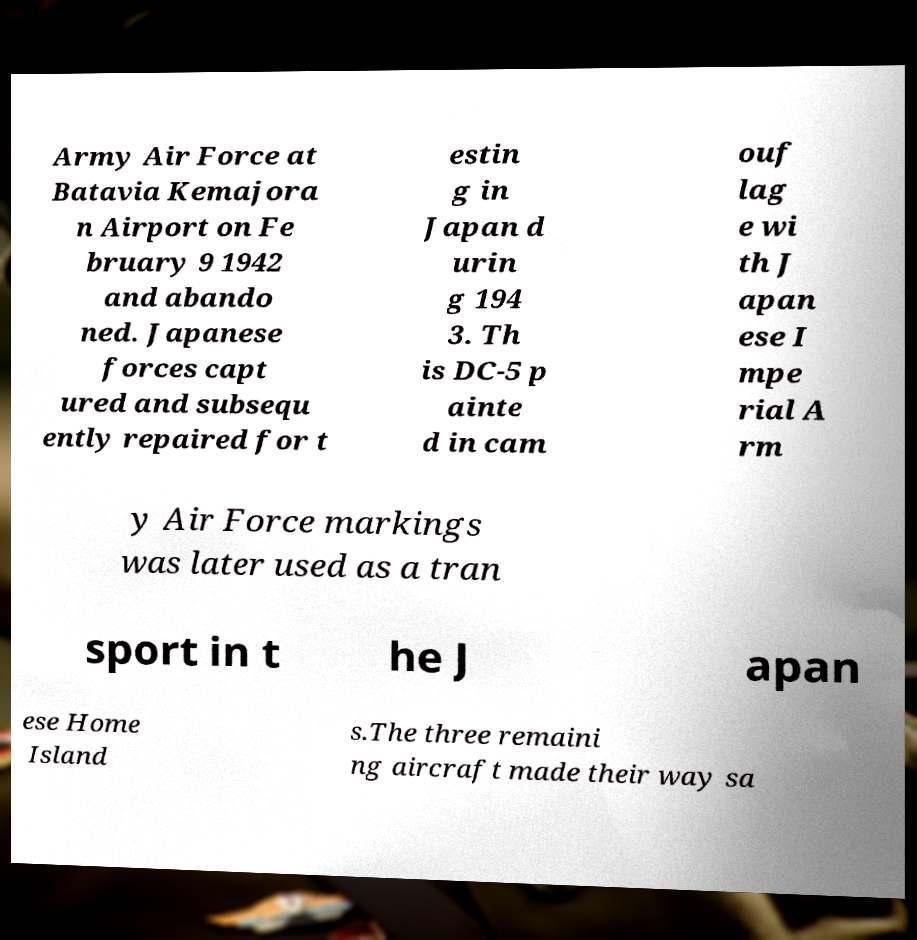Please read and relay the text visible in this image. What does it say? Army Air Force at Batavia Kemajora n Airport on Fe bruary 9 1942 and abando ned. Japanese forces capt ured and subsequ ently repaired for t estin g in Japan d urin g 194 3. Th is DC-5 p ainte d in cam ouf lag e wi th J apan ese I mpe rial A rm y Air Force markings was later used as a tran sport in t he J apan ese Home Island s.The three remaini ng aircraft made their way sa 